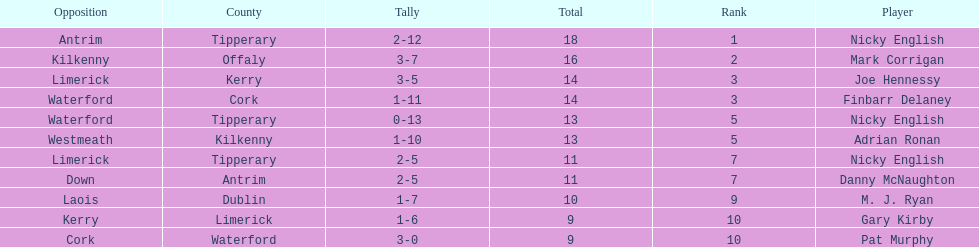What was the combined total of nicky english and mark corrigan? 34. 